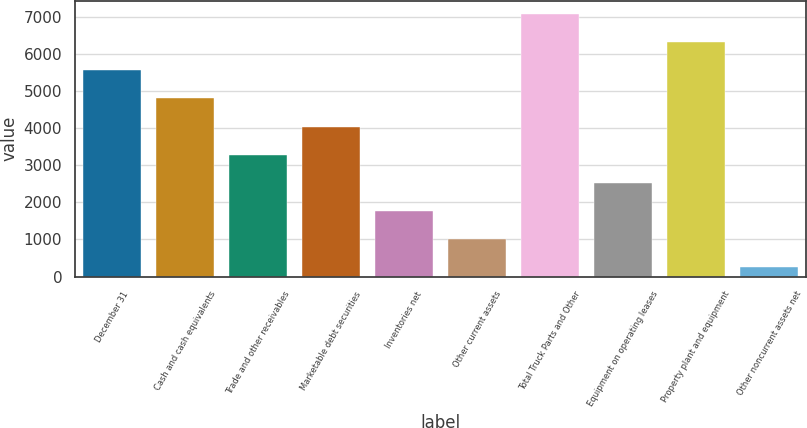Convert chart to OTSL. <chart><loc_0><loc_0><loc_500><loc_500><bar_chart><fcel>December 31<fcel>Cash and cash equivalents<fcel>Trade and other receivables<fcel>Marketable debt securities<fcel>Inventories net<fcel>Other current assets<fcel>Total Truck Parts and Other<fcel>Equipment on operating leases<fcel>Property plant and equipment<fcel>Other noncurrent assets net<nl><fcel>5557.43<fcel>4799.14<fcel>3282.56<fcel>4040.85<fcel>1765.98<fcel>1007.69<fcel>7074.01<fcel>2524.27<fcel>6315.72<fcel>249.4<nl></chart> 